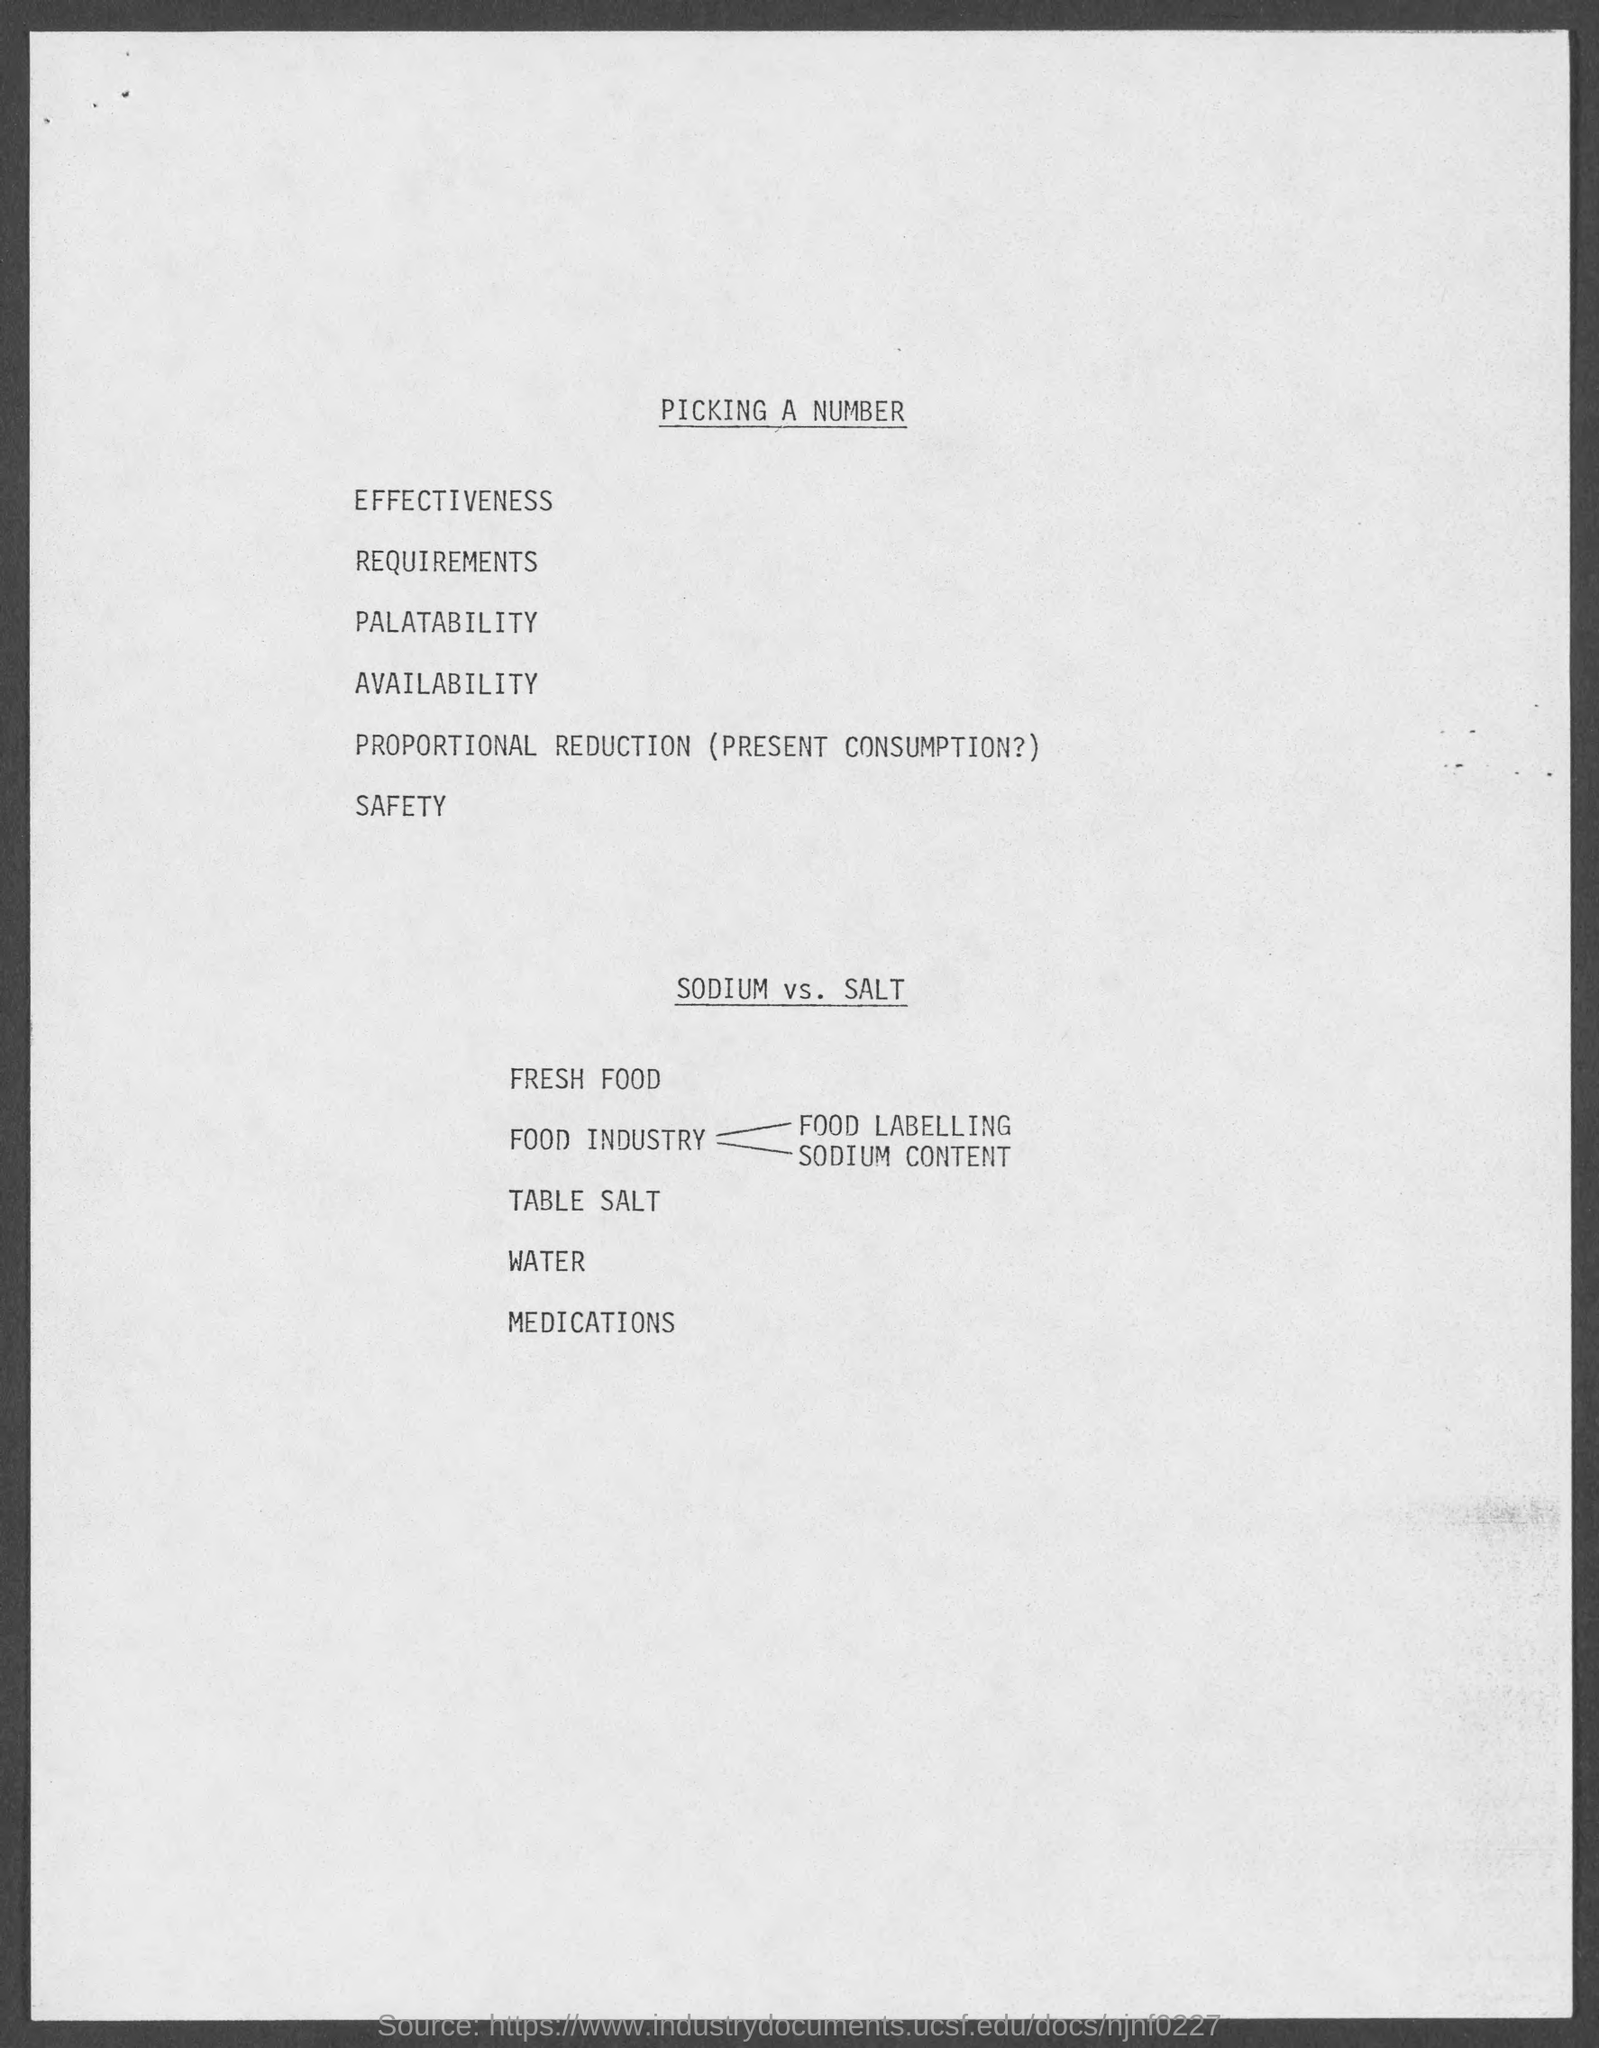Give some essential details in this illustration. The heading at the top of the page is 'Picking a Number'. 